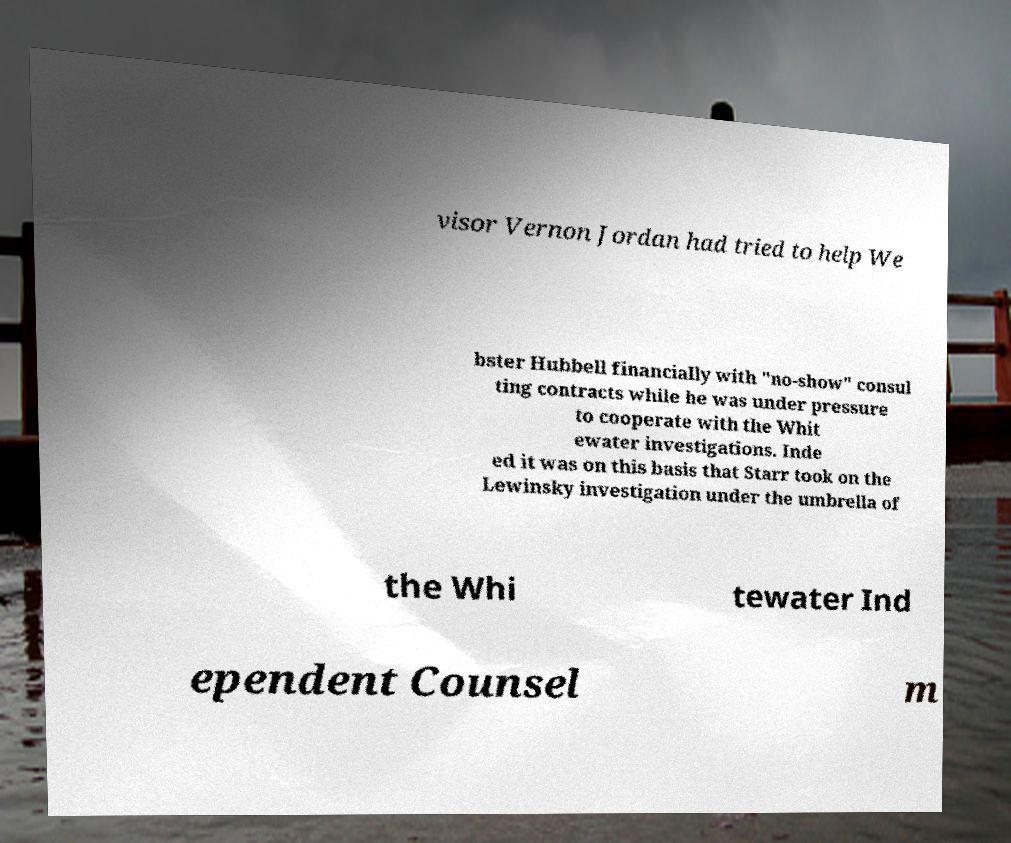Please read and relay the text visible in this image. What does it say? visor Vernon Jordan had tried to help We bster Hubbell financially with "no-show" consul ting contracts while he was under pressure to cooperate with the Whit ewater investigations. Inde ed it was on this basis that Starr took on the Lewinsky investigation under the umbrella of the Whi tewater Ind ependent Counsel m 